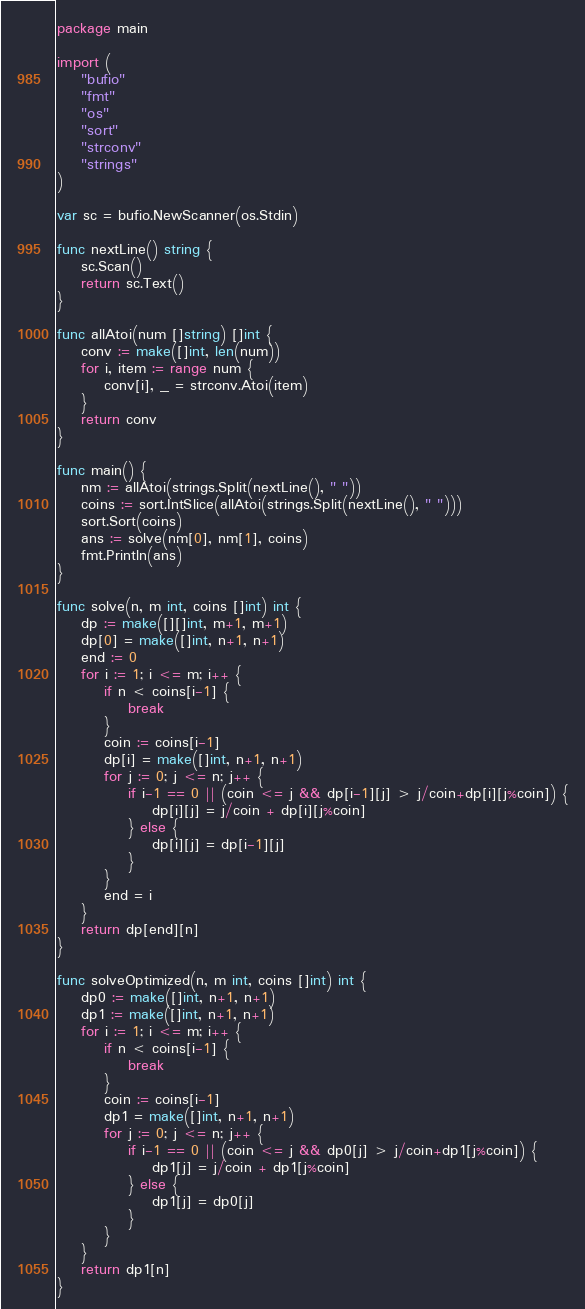<code> <loc_0><loc_0><loc_500><loc_500><_Go_>package main

import (
	"bufio"
	"fmt"
	"os"
	"sort"
	"strconv"
	"strings"
)

var sc = bufio.NewScanner(os.Stdin)

func nextLine() string {
	sc.Scan()
	return sc.Text()
}

func allAtoi(num []string) []int {
	conv := make([]int, len(num))
	for i, item := range num {
		conv[i], _ = strconv.Atoi(item)
	}
	return conv
}

func main() {
	nm := allAtoi(strings.Split(nextLine(), " "))
	coins := sort.IntSlice(allAtoi(strings.Split(nextLine(), " ")))
	sort.Sort(coins)
	ans := solve(nm[0], nm[1], coins)
	fmt.Println(ans)
}

func solve(n, m int, coins []int) int {
	dp := make([][]int, m+1, m+1)
	dp[0] = make([]int, n+1, n+1)
	end := 0
	for i := 1; i <= m; i++ {
		if n < coins[i-1] {
			break
		}
		coin := coins[i-1]
		dp[i] = make([]int, n+1, n+1)
		for j := 0; j <= n; j++ {
			if i-1 == 0 || (coin <= j && dp[i-1][j] > j/coin+dp[i][j%coin]) {
				dp[i][j] = j/coin + dp[i][j%coin]
			} else {
				dp[i][j] = dp[i-1][j]
			}
		}
		end = i
	}
	return dp[end][n]
}

func solveOptimized(n, m int, coins []int) int {
	dp0 := make([]int, n+1, n+1)
	dp1 := make([]int, n+1, n+1)
	for i := 1; i <= m; i++ {
		if n < coins[i-1] {
			break
		}
		coin := coins[i-1]
		dp1 = make([]int, n+1, n+1)
		for j := 0; j <= n; j++ {
			if i-1 == 0 || (coin <= j && dp0[j] > j/coin+dp1[j%coin]) {
				dp1[j] = j/coin + dp1[j%coin]
			} else {
				dp1[j] = dp0[j]
			}
		}
	}
	return dp1[n]
}

</code> 